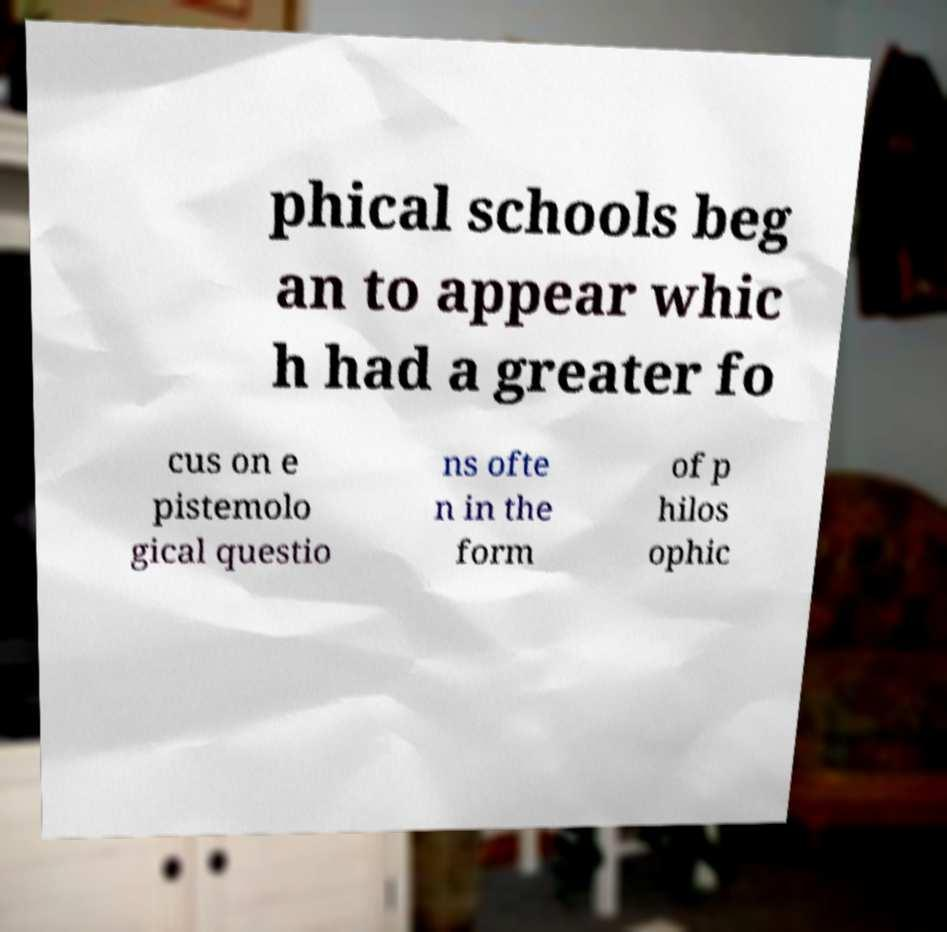Could you extract and type out the text from this image? phical schools beg an to appear whic h had a greater fo cus on e pistemolo gical questio ns ofte n in the form of p hilos ophic 